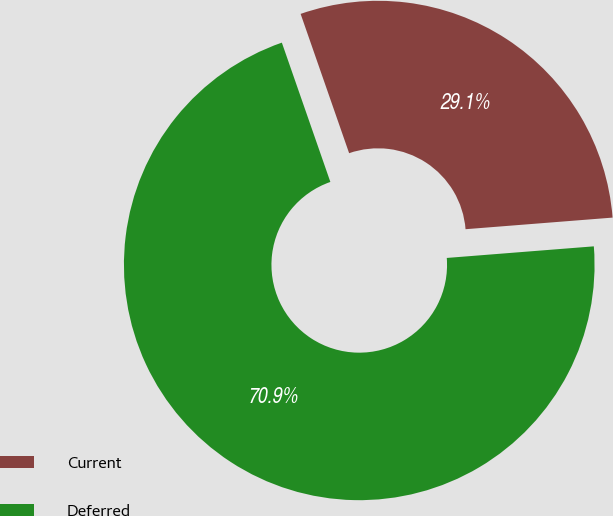Convert chart. <chart><loc_0><loc_0><loc_500><loc_500><pie_chart><fcel>Current<fcel>Deferred<nl><fcel>29.08%<fcel>70.92%<nl></chart> 